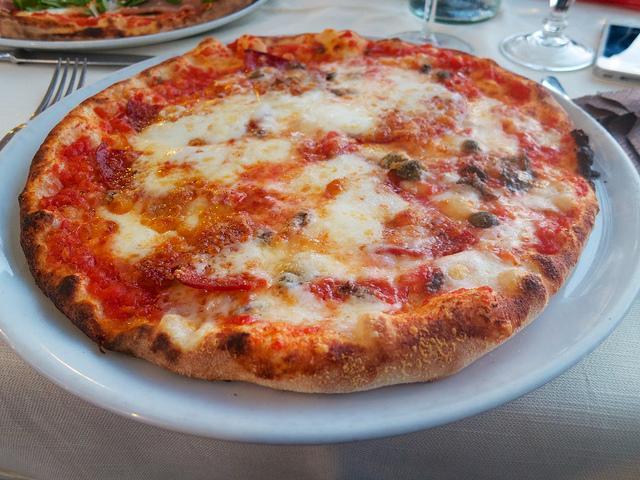How many wine glasses are there?
Give a very brief answer. 1. How many bears are in the picture?
Give a very brief answer. 0. 